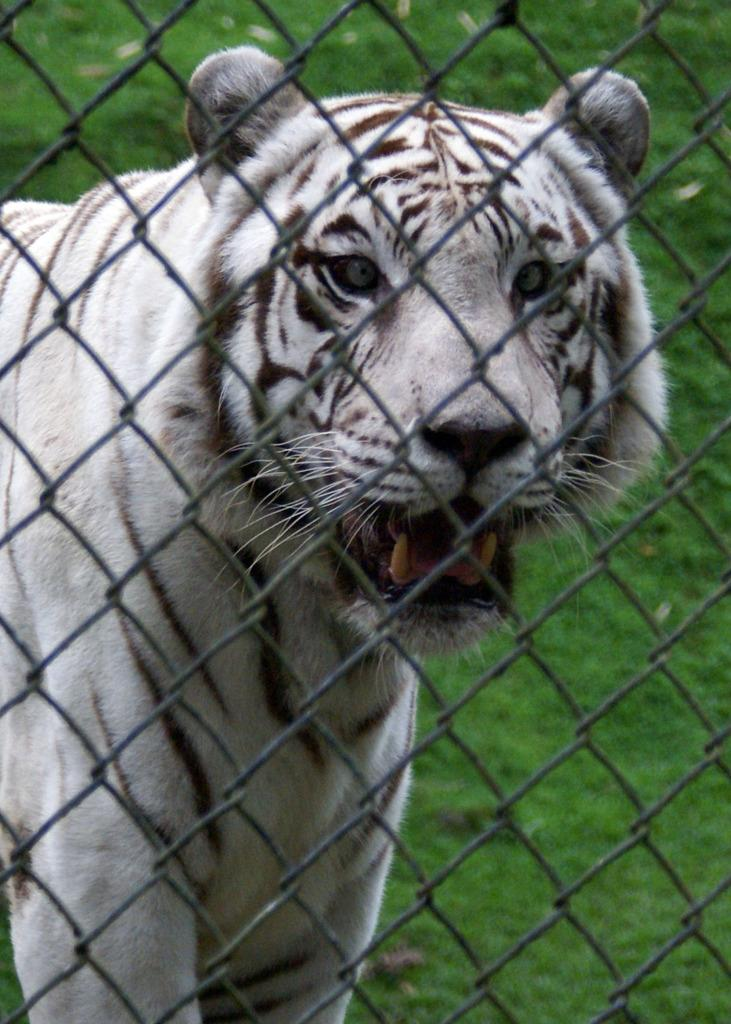What type of animal is in the image? There is a tiger in the image. What is in front of the tiger? There is a net in front of the tiger. What can be seen in the background of the image? There is grass visible in the background of the image. What type of linen is being used to create the smoke in the image? There is no linen or smoke present in the image; it features a tiger with a net in front of it and grass in the background. 